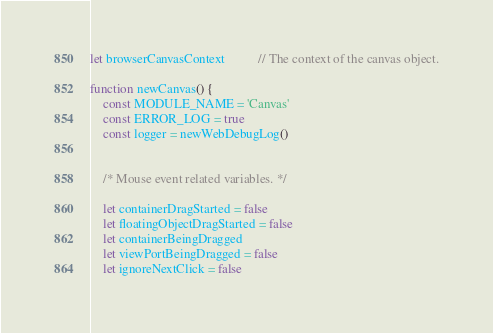Convert code to text. <code><loc_0><loc_0><loc_500><loc_500><_JavaScript_>
let browserCanvasContext          // The context of the canvas object.

function newCanvas() {
    const MODULE_NAME = 'Canvas'
    const ERROR_LOG = true
    const logger = newWebDebugLog()


    /* Mouse event related variables. */

    let containerDragStarted = false
    let floatingObjectDragStarted = false
    let containerBeingDragged
    let viewPortBeingDragged = false
    let ignoreNextClick = false</code> 